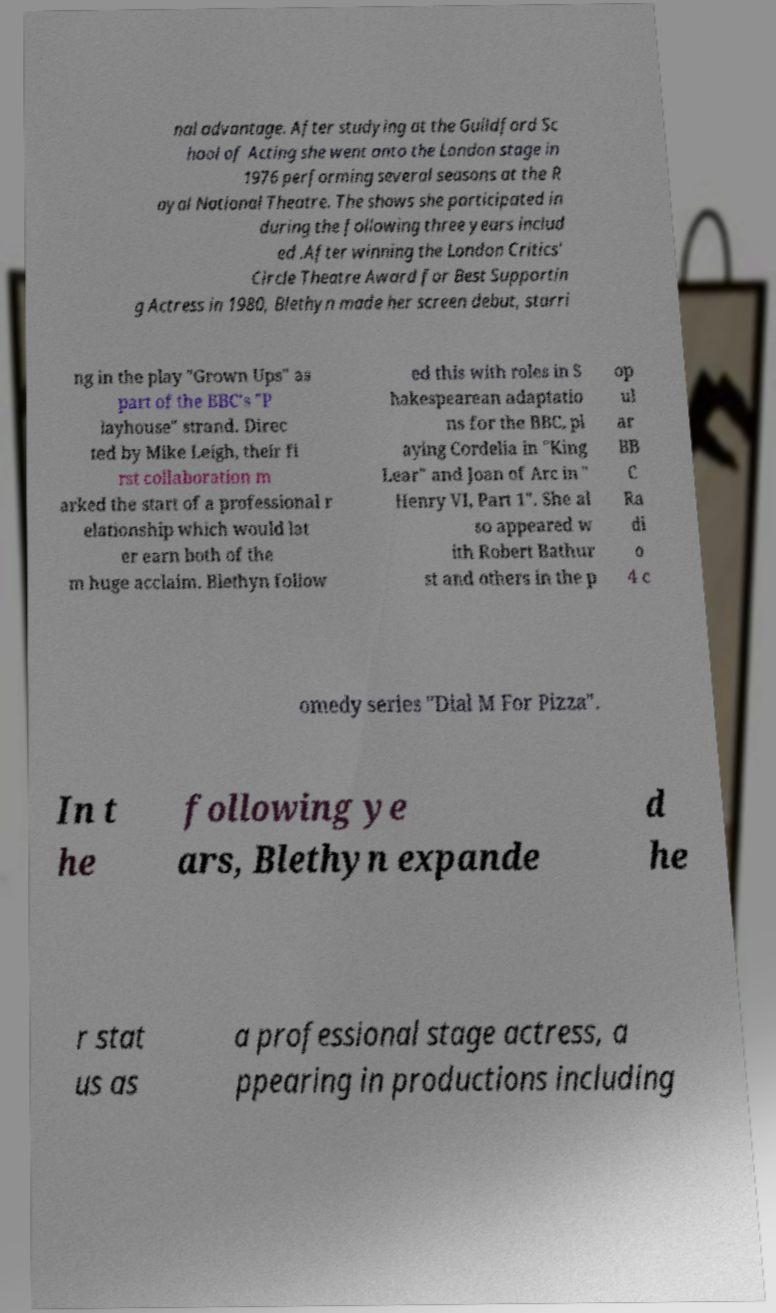Could you assist in decoding the text presented in this image and type it out clearly? nal advantage. After studying at the Guildford Sc hool of Acting she went onto the London stage in 1976 performing several seasons at the R oyal National Theatre. The shows she participated in during the following three years includ ed .After winning the London Critics' Circle Theatre Award for Best Supportin g Actress in 1980, Blethyn made her screen debut, starri ng in the play "Grown Ups" as part of the BBC's "P layhouse" strand. Direc ted by Mike Leigh, their fi rst collaboration m arked the start of a professional r elationship which would lat er earn both of the m huge acclaim. Blethyn follow ed this with roles in S hakespearean adaptatio ns for the BBC, pl aying Cordelia in "King Lear" and Joan of Arc in " Henry VI, Part 1". She al so appeared w ith Robert Bathur st and others in the p op ul ar BB C Ra di o 4 c omedy series "Dial M For Pizza". In t he following ye ars, Blethyn expande d he r stat us as a professional stage actress, a ppearing in productions including 